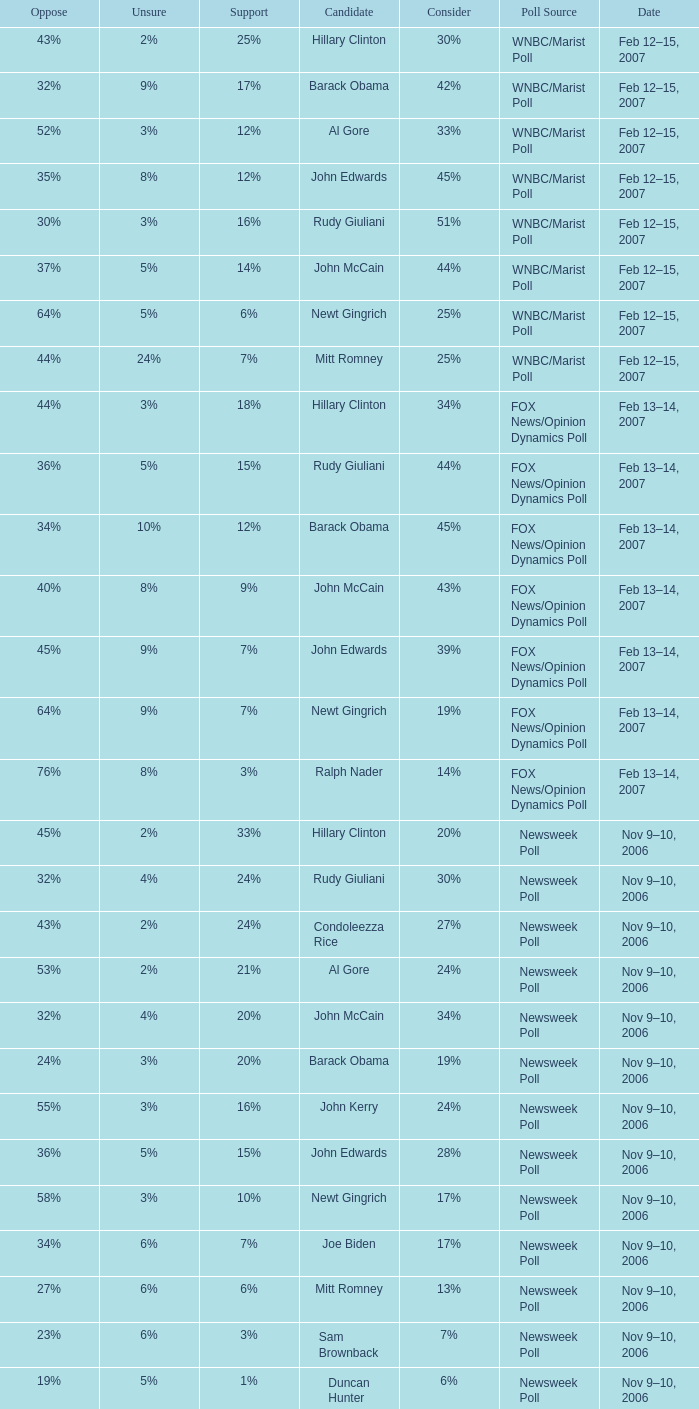What percentage of people were opposed to the candidate based on the Time Poll poll that showed 6% of people were unsure? 34%. Can you parse all the data within this table? {'header': ['Oppose', 'Unsure', 'Support', 'Candidate', 'Consider', 'Poll Source', 'Date'], 'rows': [['43%', '2%', '25%', 'Hillary Clinton', '30%', 'WNBC/Marist Poll', 'Feb 12–15, 2007'], ['32%', '9%', '17%', 'Barack Obama', '42%', 'WNBC/Marist Poll', 'Feb 12–15, 2007'], ['52%', '3%', '12%', 'Al Gore', '33%', 'WNBC/Marist Poll', 'Feb 12–15, 2007'], ['35%', '8%', '12%', 'John Edwards', '45%', 'WNBC/Marist Poll', 'Feb 12–15, 2007'], ['30%', '3%', '16%', 'Rudy Giuliani', '51%', 'WNBC/Marist Poll', 'Feb 12–15, 2007'], ['37%', '5%', '14%', 'John McCain', '44%', 'WNBC/Marist Poll', 'Feb 12–15, 2007'], ['64%', '5%', '6%', 'Newt Gingrich', '25%', 'WNBC/Marist Poll', 'Feb 12–15, 2007'], ['44%', '24%', '7%', 'Mitt Romney', '25%', 'WNBC/Marist Poll', 'Feb 12–15, 2007'], ['44%', '3%', '18%', 'Hillary Clinton', '34%', 'FOX News/Opinion Dynamics Poll', 'Feb 13–14, 2007'], ['36%', '5%', '15%', 'Rudy Giuliani', '44%', 'FOX News/Opinion Dynamics Poll', 'Feb 13–14, 2007'], ['34%', '10%', '12%', 'Barack Obama', '45%', 'FOX News/Opinion Dynamics Poll', 'Feb 13–14, 2007'], ['40%', '8%', '9%', 'John McCain', '43%', 'FOX News/Opinion Dynamics Poll', 'Feb 13–14, 2007'], ['45%', '9%', '7%', 'John Edwards', '39%', 'FOX News/Opinion Dynamics Poll', 'Feb 13–14, 2007'], ['64%', '9%', '7%', 'Newt Gingrich', '19%', 'FOX News/Opinion Dynamics Poll', 'Feb 13–14, 2007'], ['76%', '8%', '3%', 'Ralph Nader', '14%', 'FOX News/Opinion Dynamics Poll', 'Feb 13–14, 2007'], ['45%', '2%', '33%', 'Hillary Clinton', '20%', 'Newsweek Poll', 'Nov 9–10, 2006'], ['32%', '4%', '24%', 'Rudy Giuliani', '30%', 'Newsweek Poll', 'Nov 9–10, 2006'], ['43%', '2%', '24%', 'Condoleezza Rice', '27%', 'Newsweek Poll', 'Nov 9–10, 2006'], ['53%', '2%', '21%', 'Al Gore', '24%', 'Newsweek Poll', 'Nov 9–10, 2006'], ['32%', '4%', '20%', 'John McCain', '34%', 'Newsweek Poll', 'Nov 9–10, 2006'], ['24%', '3%', '20%', 'Barack Obama', '19%', 'Newsweek Poll', 'Nov 9–10, 2006'], ['55%', '3%', '16%', 'John Kerry', '24%', 'Newsweek Poll', 'Nov 9–10, 2006'], ['36%', '5%', '15%', 'John Edwards', '28%', 'Newsweek Poll', 'Nov 9–10, 2006'], ['58%', '3%', '10%', 'Newt Gingrich', '17%', 'Newsweek Poll', 'Nov 9–10, 2006'], ['34%', '6%', '7%', 'Joe Biden', '17%', 'Newsweek Poll', 'Nov 9–10, 2006'], ['27%', '6%', '6%', 'Mitt Romney', '13%', 'Newsweek Poll', 'Nov 9–10, 2006'], ['23%', '6%', '3%', 'Sam Brownback', '7%', 'Newsweek Poll', 'Nov 9–10, 2006'], ['19%', '5%', '1%', 'Duncan Hunter', '6%', 'Newsweek Poll', 'Nov 9–10, 2006'], ['19%', '18%', '17%', 'Rudy Giuliani', '55%', 'Time Poll', 'Oct 3–4, 2006'], ['37%', '5%', '23%', 'Hillary Rodham Clinton', '36%', 'Time Poll', 'Oct 3–4, 2006'], ['19%', '13%', '12%', 'John McCain', '56%', 'Time Poll', 'Oct 3–4, 2006'], ['35%', '5%', '16%', 'Al Gore', '44%', 'Time Poll', 'Oct 3–4, 2006'], ['34%', '9%', '14%', 'John Kerry', '43%', 'Time Poll', 'Oct 3–4, 2006'], ['14%', '15%', '17%', 'Rudy Giuliani', '54%', 'Time Poll', 'Jul 13–17, 2006'], ['34%', '6%', '19%', 'Hillary Rodham Clinton', '41%', 'Time Poll', 'Jul 13–17, 2006'], ['13%', '22%', '12%', 'John McCain', '52%', 'Time Poll', 'Jul 13–17, 2006'], ['32%', '7%', '16%', 'Al Gore', '45%', 'Time Poll', 'Jul 13–17, 2006'], ['30%', '10%', '12%', 'John Kerry', '48%', 'Time Poll', 'Jul 13–17, 2006'], ['47%', '3%', '22%', 'Hillary Rodham Clinton', '28%', 'CNN Poll', 'Jun 1–6, 2006'], ['48%', '3%', '17%', 'Al Gore', '32%', 'CNN Poll', 'Jun 1–6, 2006'], ['47%', '4%', '14%', 'John Kerry', '35%', 'CNN Poll', 'Jun 1–6, 2006'], ['30%', '6%', '19%', 'Rudolph Giuliani', '45%', 'CNN Poll', 'Jun 1–6, 2006'], ['34%', '6%', '12%', 'John McCain', '48%', 'CNN Poll', 'Jun 1–6, 2006'], ['63%', '2%', '9%', 'Jeb Bush', '26%', 'CNN Poll', 'Jun 1–6, 2006'], ['42%', '1%', '19%', 'Hillary Clinton', '38%', 'ABC News/Washington Post Poll', 'May 11–15, 2006'], ['28%', '6%', '9%', 'John McCain', '57%', 'ABC News/Washington Post Poll', 'May 11–15, 2006'], ['44%', '2%', '35%', 'Hillary Clinton', '19%', 'FOX News/Opinion Dynamics Poll', 'Feb 7–8, 2006'], ['24%', '6%', '33%', 'Rudy Giuliani', '38%', 'FOX News/Opinion Dynamics Poll', 'Feb 7–8, 2006'], ['22%', '7%', '30%', 'John McCain', '40%', 'FOX News/Opinion Dynamics Poll', 'Feb 7–8, 2006'], ['45%', '3%', '29%', 'John Kerry', '23%', 'FOX News/Opinion Dynamics Poll', 'Feb 7–8, 2006'], ['46%', '3%', '14%', 'Condoleezza Rice', '38%', 'FOX News/Opinion Dynamics Poll', 'Feb 7–8, 2006'], ['51%', '1%', '16%', 'Hillary Rodham Clinton', '32%', 'CNN/USA Today/Gallup Poll', 'Jan 20–22, 2006'], ['15%', '15%', '23%', 'John McCain', '46%', 'Diageo/Hotline Poll', 'Nov 11–15, 2005'], ['40%', '1%', '28%', 'Hillary Rodham Clinton', '31%', 'CNN/USA Today/Gallup Poll', 'May 20–22, 2005'], ['45%', '2%', '20%', 'Hillary Rodham Clinton', '33%', 'CNN/USA Today/Gallup Poll', 'Jun 9–10, 2003']]} 